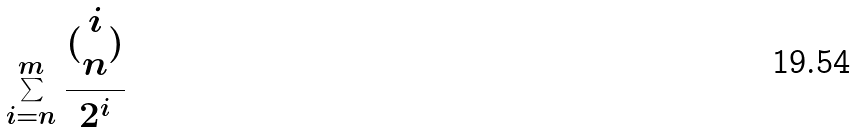<formula> <loc_0><loc_0><loc_500><loc_500>\sum _ { i = n } ^ { m } \frac { ( \begin{matrix} i \\ n \end{matrix} ) } { 2 ^ { i } }</formula> 